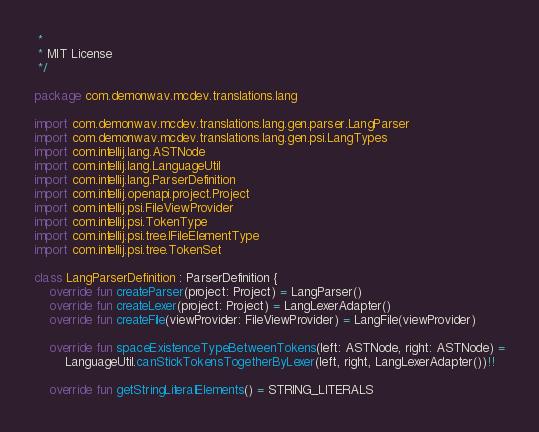<code> <loc_0><loc_0><loc_500><loc_500><_Kotlin_> *
 * MIT License
 */

package com.demonwav.mcdev.translations.lang

import com.demonwav.mcdev.translations.lang.gen.parser.LangParser
import com.demonwav.mcdev.translations.lang.gen.psi.LangTypes
import com.intellij.lang.ASTNode
import com.intellij.lang.LanguageUtil
import com.intellij.lang.ParserDefinition
import com.intellij.openapi.project.Project
import com.intellij.psi.FileViewProvider
import com.intellij.psi.TokenType
import com.intellij.psi.tree.IFileElementType
import com.intellij.psi.tree.TokenSet

class LangParserDefinition : ParserDefinition {
    override fun createParser(project: Project) = LangParser()
    override fun createLexer(project: Project) = LangLexerAdapter()
    override fun createFile(viewProvider: FileViewProvider) = LangFile(viewProvider)

    override fun spaceExistenceTypeBetweenTokens(left: ASTNode, right: ASTNode) =
        LanguageUtil.canStickTokensTogetherByLexer(left, right, LangLexerAdapter())!!

    override fun getStringLiteralElements() = STRING_LITERALS</code> 